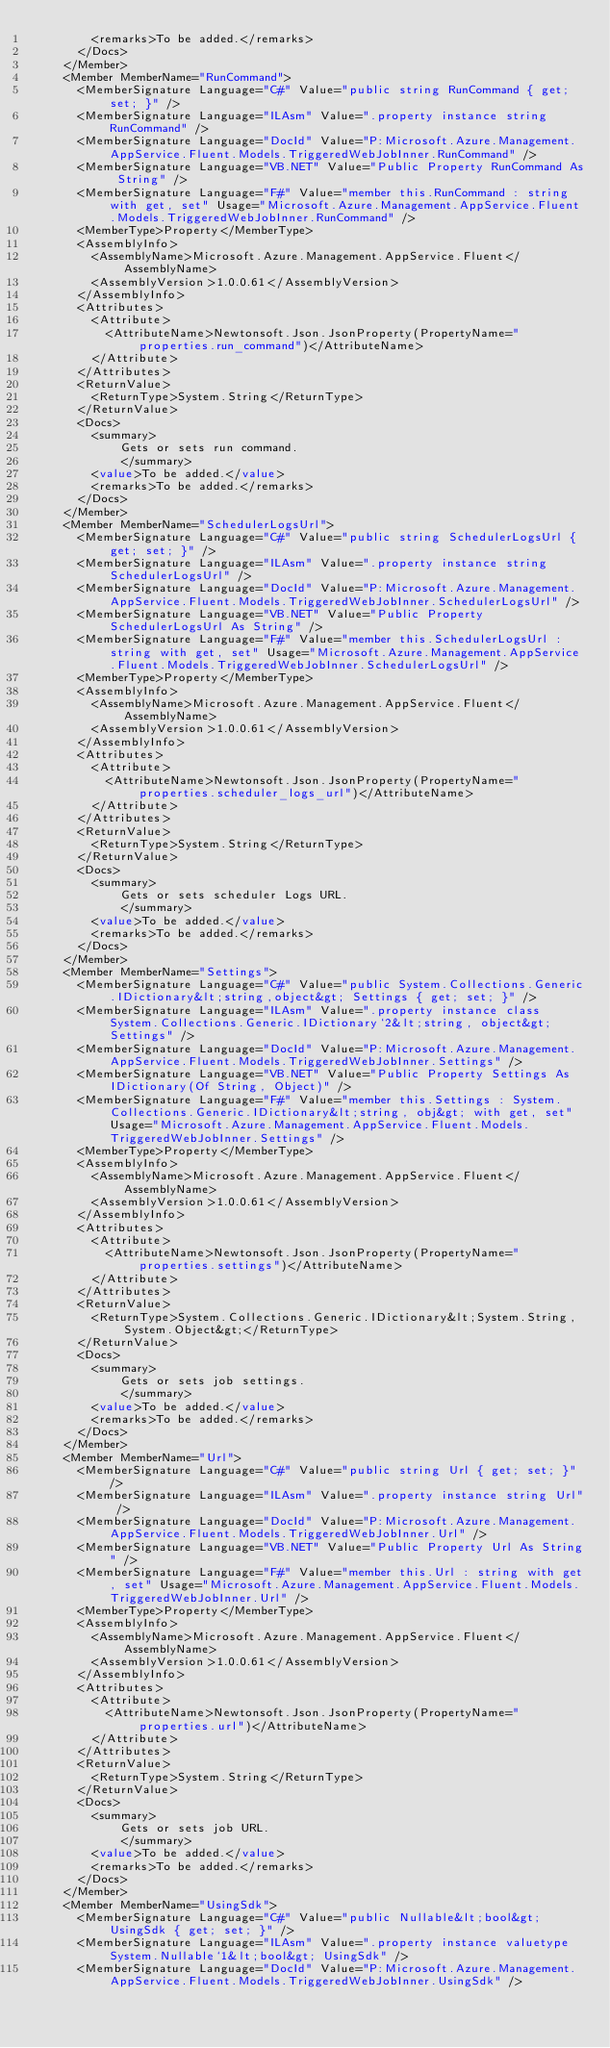Convert code to text. <code><loc_0><loc_0><loc_500><loc_500><_XML_>        <remarks>To be added.</remarks>
      </Docs>
    </Member>
    <Member MemberName="RunCommand">
      <MemberSignature Language="C#" Value="public string RunCommand { get; set; }" />
      <MemberSignature Language="ILAsm" Value=".property instance string RunCommand" />
      <MemberSignature Language="DocId" Value="P:Microsoft.Azure.Management.AppService.Fluent.Models.TriggeredWebJobInner.RunCommand" />
      <MemberSignature Language="VB.NET" Value="Public Property RunCommand As String" />
      <MemberSignature Language="F#" Value="member this.RunCommand : string with get, set" Usage="Microsoft.Azure.Management.AppService.Fluent.Models.TriggeredWebJobInner.RunCommand" />
      <MemberType>Property</MemberType>
      <AssemblyInfo>
        <AssemblyName>Microsoft.Azure.Management.AppService.Fluent</AssemblyName>
        <AssemblyVersion>1.0.0.61</AssemblyVersion>
      </AssemblyInfo>
      <Attributes>
        <Attribute>
          <AttributeName>Newtonsoft.Json.JsonProperty(PropertyName="properties.run_command")</AttributeName>
        </Attribute>
      </Attributes>
      <ReturnValue>
        <ReturnType>System.String</ReturnType>
      </ReturnValue>
      <Docs>
        <summary>
            Gets or sets run command.
            </summary>
        <value>To be added.</value>
        <remarks>To be added.</remarks>
      </Docs>
    </Member>
    <Member MemberName="SchedulerLogsUrl">
      <MemberSignature Language="C#" Value="public string SchedulerLogsUrl { get; set; }" />
      <MemberSignature Language="ILAsm" Value=".property instance string SchedulerLogsUrl" />
      <MemberSignature Language="DocId" Value="P:Microsoft.Azure.Management.AppService.Fluent.Models.TriggeredWebJobInner.SchedulerLogsUrl" />
      <MemberSignature Language="VB.NET" Value="Public Property SchedulerLogsUrl As String" />
      <MemberSignature Language="F#" Value="member this.SchedulerLogsUrl : string with get, set" Usage="Microsoft.Azure.Management.AppService.Fluent.Models.TriggeredWebJobInner.SchedulerLogsUrl" />
      <MemberType>Property</MemberType>
      <AssemblyInfo>
        <AssemblyName>Microsoft.Azure.Management.AppService.Fluent</AssemblyName>
        <AssemblyVersion>1.0.0.61</AssemblyVersion>
      </AssemblyInfo>
      <Attributes>
        <Attribute>
          <AttributeName>Newtonsoft.Json.JsonProperty(PropertyName="properties.scheduler_logs_url")</AttributeName>
        </Attribute>
      </Attributes>
      <ReturnValue>
        <ReturnType>System.String</ReturnType>
      </ReturnValue>
      <Docs>
        <summary>
            Gets or sets scheduler Logs URL.
            </summary>
        <value>To be added.</value>
        <remarks>To be added.</remarks>
      </Docs>
    </Member>
    <Member MemberName="Settings">
      <MemberSignature Language="C#" Value="public System.Collections.Generic.IDictionary&lt;string,object&gt; Settings { get; set; }" />
      <MemberSignature Language="ILAsm" Value=".property instance class System.Collections.Generic.IDictionary`2&lt;string, object&gt; Settings" />
      <MemberSignature Language="DocId" Value="P:Microsoft.Azure.Management.AppService.Fluent.Models.TriggeredWebJobInner.Settings" />
      <MemberSignature Language="VB.NET" Value="Public Property Settings As IDictionary(Of String, Object)" />
      <MemberSignature Language="F#" Value="member this.Settings : System.Collections.Generic.IDictionary&lt;string, obj&gt; with get, set" Usage="Microsoft.Azure.Management.AppService.Fluent.Models.TriggeredWebJobInner.Settings" />
      <MemberType>Property</MemberType>
      <AssemblyInfo>
        <AssemblyName>Microsoft.Azure.Management.AppService.Fluent</AssemblyName>
        <AssemblyVersion>1.0.0.61</AssemblyVersion>
      </AssemblyInfo>
      <Attributes>
        <Attribute>
          <AttributeName>Newtonsoft.Json.JsonProperty(PropertyName="properties.settings")</AttributeName>
        </Attribute>
      </Attributes>
      <ReturnValue>
        <ReturnType>System.Collections.Generic.IDictionary&lt;System.String,System.Object&gt;</ReturnType>
      </ReturnValue>
      <Docs>
        <summary>
            Gets or sets job settings.
            </summary>
        <value>To be added.</value>
        <remarks>To be added.</remarks>
      </Docs>
    </Member>
    <Member MemberName="Url">
      <MemberSignature Language="C#" Value="public string Url { get; set; }" />
      <MemberSignature Language="ILAsm" Value=".property instance string Url" />
      <MemberSignature Language="DocId" Value="P:Microsoft.Azure.Management.AppService.Fluent.Models.TriggeredWebJobInner.Url" />
      <MemberSignature Language="VB.NET" Value="Public Property Url As String" />
      <MemberSignature Language="F#" Value="member this.Url : string with get, set" Usage="Microsoft.Azure.Management.AppService.Fluent.Models.TriggeredWebJobInner.Url" />
      <MemberType>Property</MemberType>
      <AssemblyInfo>
        <AssemblyName>Microsoft.Azure.Management.AppService.Fluent</AssemblyName>
        <AssemblyVersion>1.0.0.61</AssemblyVersion>
      </AssemblyInfo>
      <Attributes>
        <Attribute>
          <AttributeName>Newtonsoft.Json.JsonProperty(PropertyName="properties.url")</AttributeName>
        </Attribute>
      </Attributes>
      <ReturnValue>
        <ReturnType>System.String</ReturnType>
      </ReturnValue>
      <Docs>
        <summary>
            Gets or sets job URL.
            </summary>
        <value>To be added.</value>
        <remarks>To be added.</remarks>
      </Docs>
    </Member>
    <Member MemberName="UsingSdk">
      <MemberSignature Language="C#" Value="public Nullable&lt;bool&gt; UsingSdk { get; set; }" />
      <MemberSignature Language="ILAsm" Value=".property instance valuetype System.Nullable`1&lt;bool&gt; UsingSdk" />
      <MemberSignature Language="DocId" Value="P:Microsoft.Azure.Management.AppService.Fluent.Models.TriggeredWebJobInner.UsingSdk" /></code> 